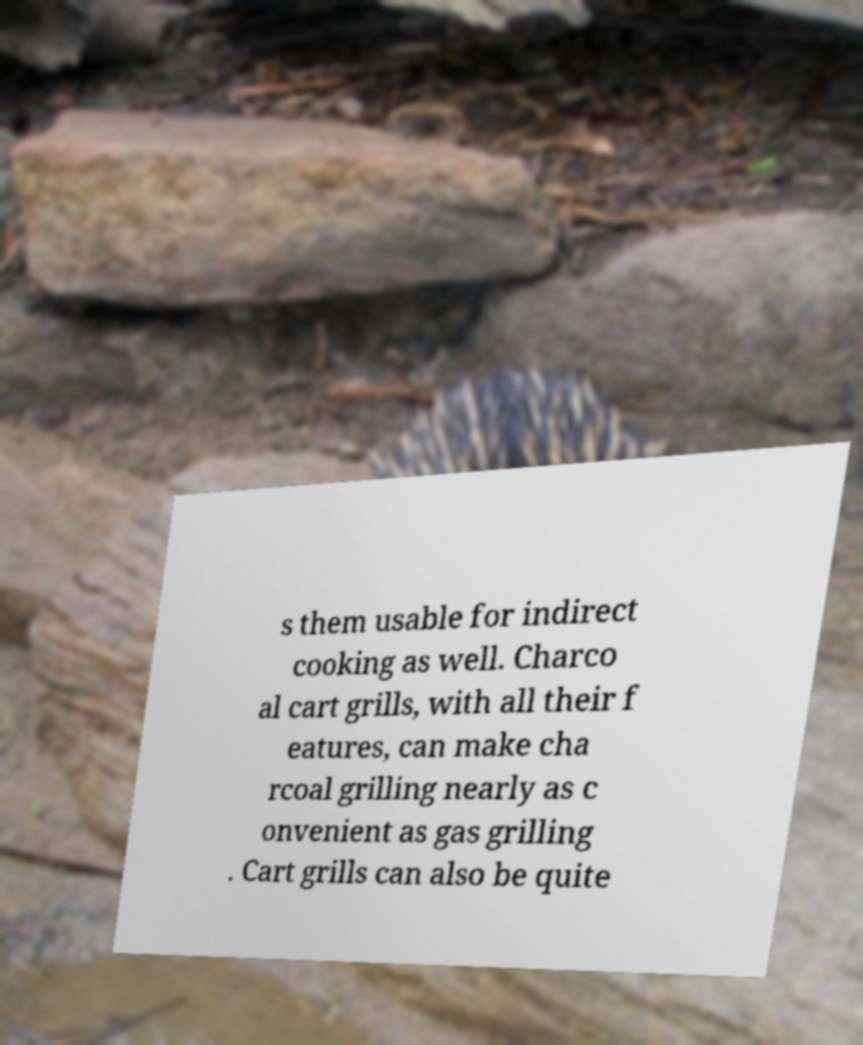Could you assist in decoding the text presented in this image and type it out clearly? s them usable for indirect cooking as well. Charco al cart grills, with all their f eatures, can make cha rcoal grilling nearly as c onvenient as gas grilling . Cart grills can also be quite 